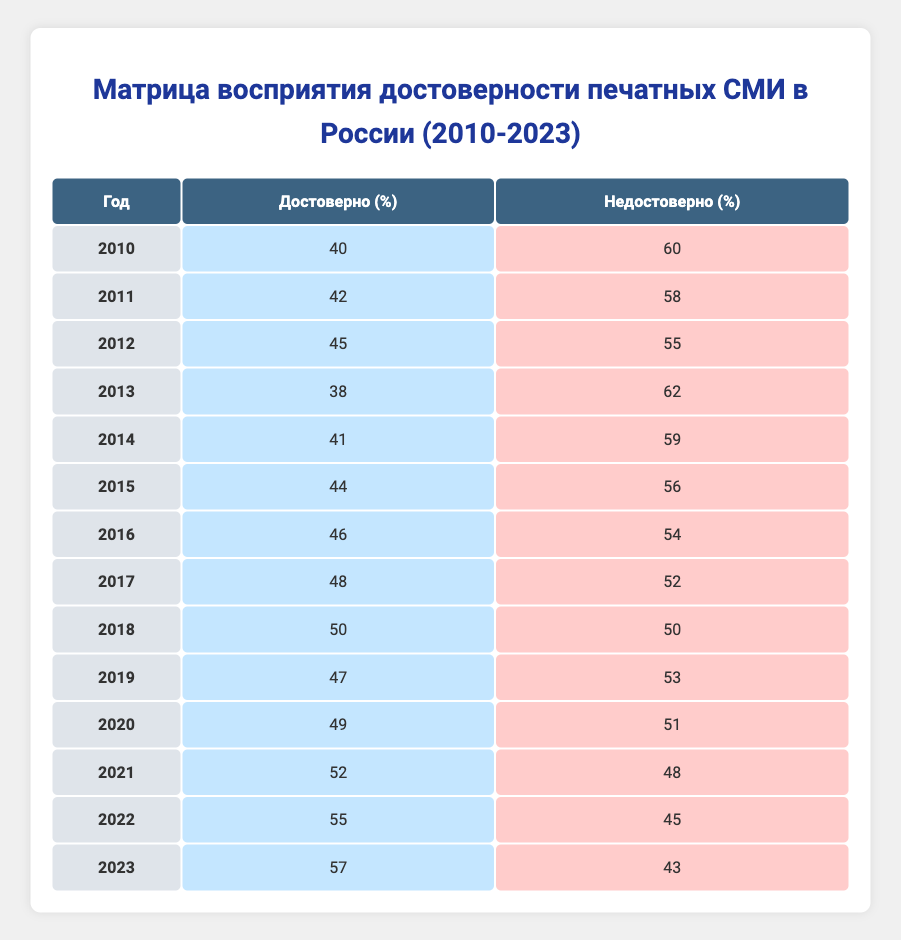What was the perception of print media credibility in 2010? In 2010, the percentage of respondents who found print media credible was 40%, while those who deemed it not credible was 60%. This is directly gathered from the table data under that specific year.
Answer: 40% Which year saw the highest percentage of people perceiving print media as credible? The year with the highest reported credibility percentage, based on the table, is 2023 with a 57% credibility rating. This value is compared to all other years to determine the maximum.
Answer: 2023 Calculate the average percentage of credibility from 2010 to 2023. To find the average credibility percentage, we first sum all the credibility values from each year: 40 + 42 + 45 + 38 + 41 + 44 + 46 + 48 + 50 + 47 + 49 + 52 + 55 + 57 = 747. There are 14 years, so we divide this sum by 14: 747 / 14 ≈ 53.36. Therefore, the average percentage of credibility is approximately 53.36%.
Answer: 53.36% Is there a year where the percentage of credible print media was less than 40%? After reviewing the data for each year, it can be observed that in 2010 the credibility percentage was only 40%, but no years before that showed a number below 40%. Thus, it can be confirmed that there are no years with a credibility percentage lower than 40%.
Answer: No What is the change in percentage of print media credibility from 2010 to 2023? To find the change, we subtract the value from 2010 from that of 2023: 57 (2023) - 40 (2010) = 17. This indicates that from 2010 to 2023, there was an increase of 17 percentage points in the credibility perception of print media.
Answer: 17 